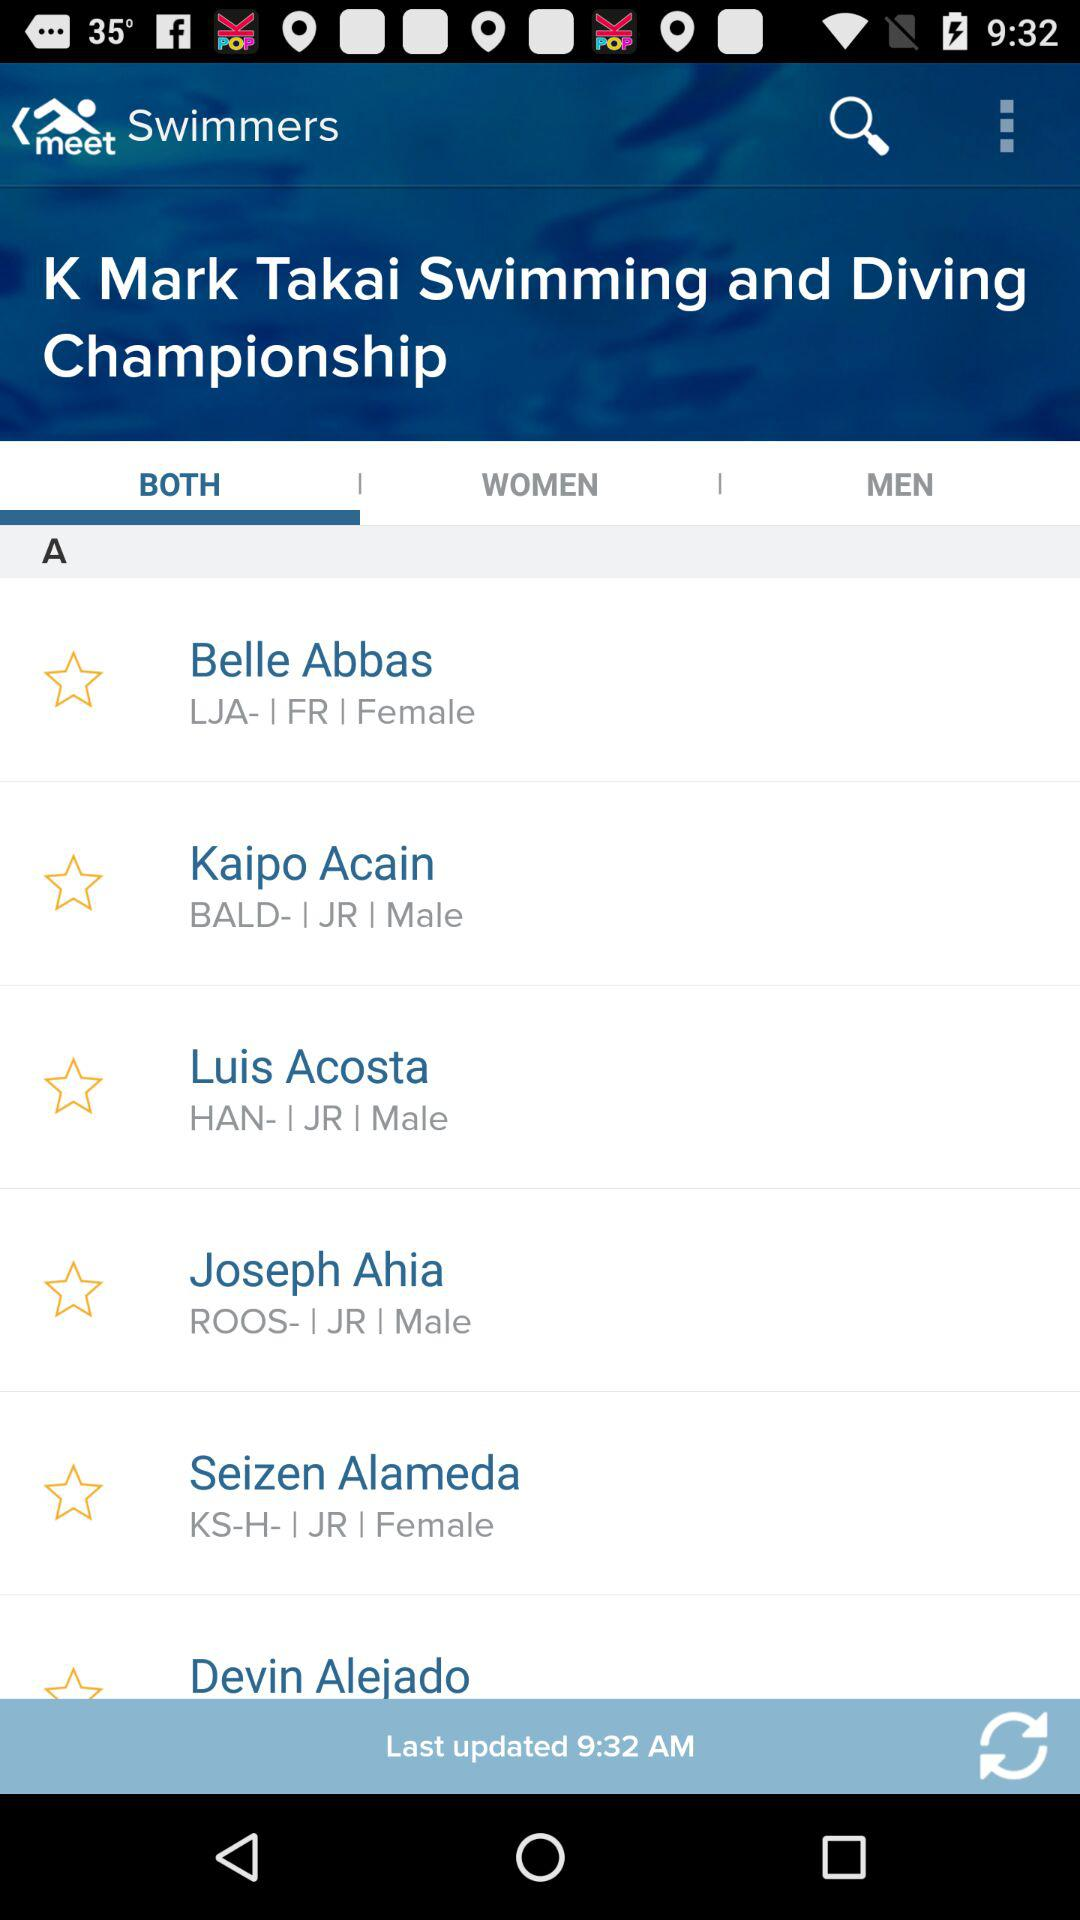How many items are in "WOMEN"?
When the provided information is insufficient, respond with <no answer>. <no answer> 